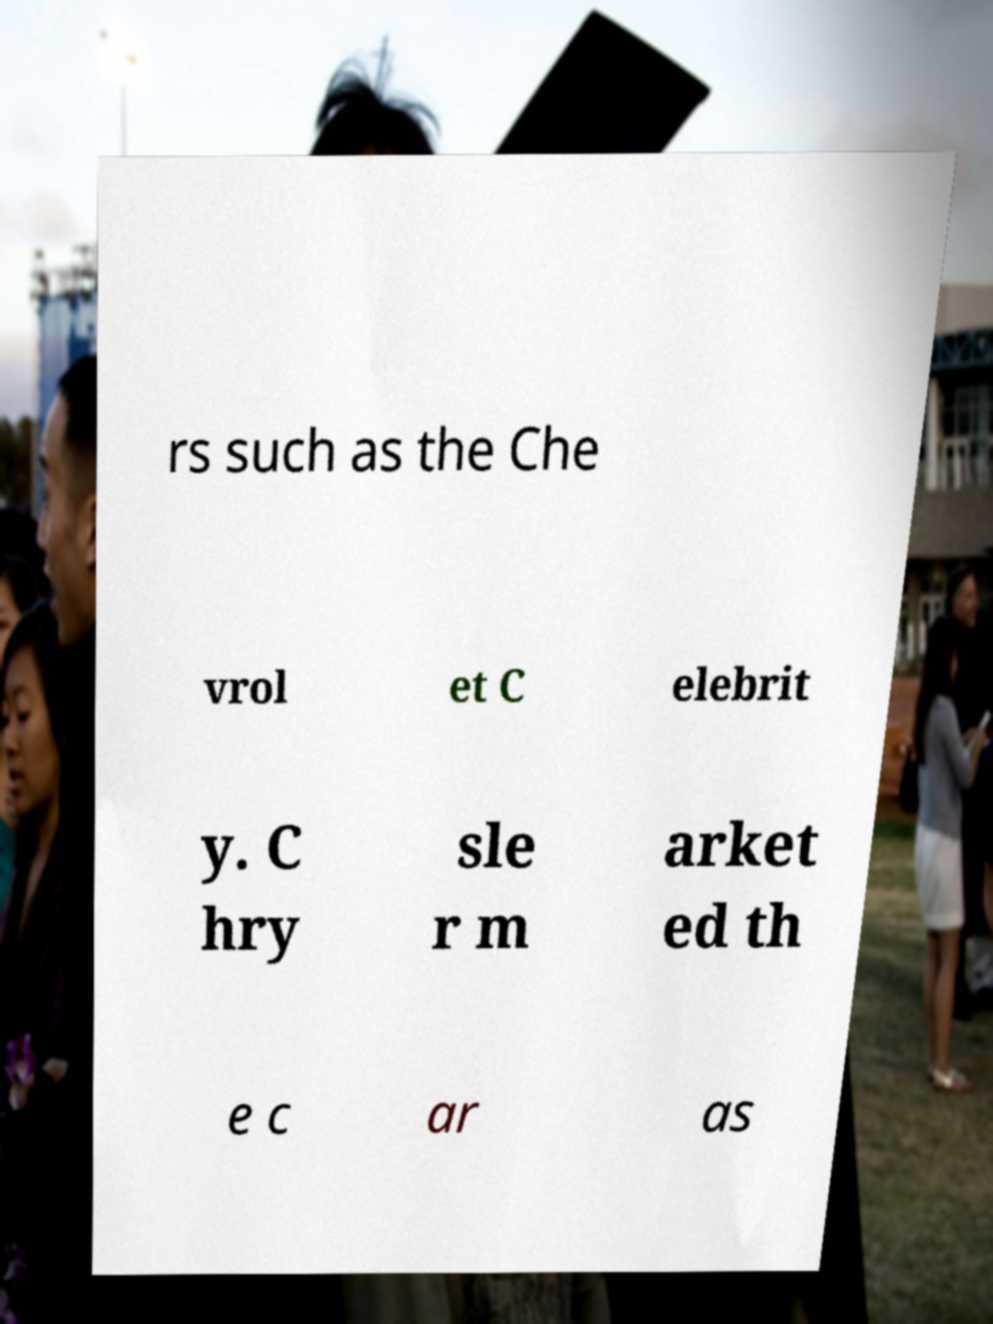Could you extract and type out the text from this image? rs such as the Che vrol et C elebrit y. C hry sle r m arket ed th e c ar as 